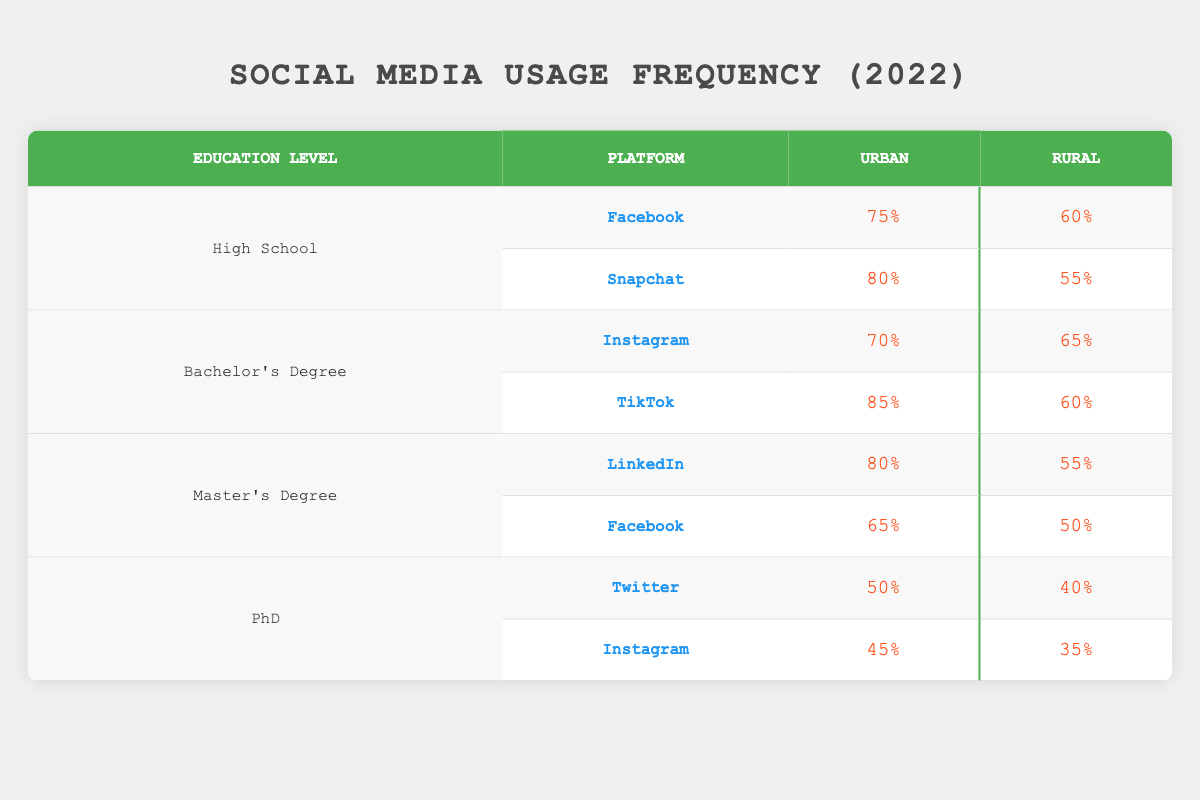What is the usage frequency of Facebook among individuals with a Bachelor's Degree in urban areas? The table shows that the usage frequency of Facebook for people with a Bachelor's Degree in the Urban area is not directly found for this degree. However, when looking at the platforms associated with this education level, Facebook is not listed, therefore, it would either be very low or zero, as other platforms like Instagram and TikTok are specified instead.
Answer: Not specified What was the highest usage frequency for Snapchat, and which education level and location does it correspond to? Looking through the table, the highest usage frequency for Snapchat is 80%, which corresponds to individuals with a High School education in Urban areas.
Answer: 80% (High School, Urban) What is the usage frequency for Instagram users with a PhD in Rural areas? The table specifically states that the usage frequency of Instagram for users with a PhD in Rural areas is 35%.
Answer: 35% Which social media platform had the highest overall usage frequency for Urban users with a Bachelor's Degree? The platforms for Urban users with a Bachelor's Degree include Instagram with 70% and TikTok with 85%. TikTok has the highest frequency among these.
Answer: TikTok (85%) Is the usage frequency for LinkedIn higher in urban areas compared to rural areas for individuals with a Master's Degree? Checking the frequencies provided in the table, LinkedIn shows 80% in Urban areas and 55% in Rural areas for Master's Degree holders. Thus, the Urban frequency is indeed higher.
Answer: Yes What is the total usage frequency for all platforms listed under the High School education level in Urban areas? The frequencies for High School in Urban areas are Facebook (75%), Snapchat (80%). The total is calculated as 75 + 80 = 155%.
Answer: 155% What percentage difference in usage frequency for Twitter exists between Urban and Rural PhD users? The usage frequency for Twitter with a PhD in Urban areas is 50% and in Rural areas it is 40%. The difference is calculated as 50 - 40 = 10%.
Answer: 10% Which education level has the lowest engagement on Instagram in Rural areas? The table shows that for Instagram, those with a PhD have the lowest usage frequency in Rural areas at 35%, lower than the other education levels.
Answer: PhD with 35% What is the average usage frequency for TikTok among Bachelor’s Degree holders in both Urban and Rural areas? The usage frequencies for TikTok among Bachelor's Degree holders are 85% in Urban areas and 60% in Rural. To find the average, calculate (85 + 60) / 2 = 72.5%.
Answer: 72.5% 